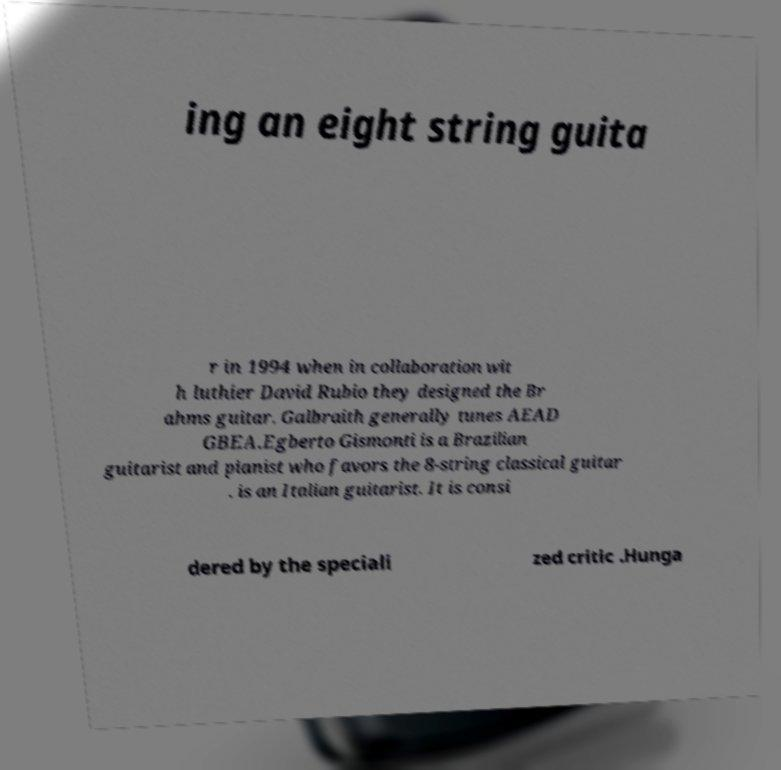Can you read and provide the text displayed in the image?This photo seems to have some interesting text. Can you extract and type it out for me? ing an eight string guita r in 1994 when in collaboration wit h luthier David Rubio they designed the Br ahms guitar. Galbraith generally tunes AEAD GBEA.Egberto Gismonti is a Brazilian guitarist and pianist who favors the 8-string classical guitar . is an Italian guitarist. It is consi dered by the speciali zed critic .Hunga 